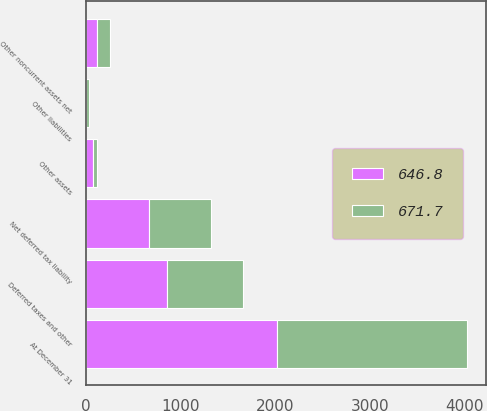Convert chart to OTSL. <chart><loc_0><loc_0><loc_500><loc_500><stacked_bar_chart><ecel><fcel>At December 31<fcel>Other noncurrent assets net<fcel>Other liabilities<fcel>Other assets<fcel>Deferred taxes and other<fcel>Net deferred tax liability<nl><fcel>646.8<fcel>2016<fcel>119.5<fcel>6.3<fcel>74.6<fcel>859.5<fcel>671.7<nl><fcel>671.7<fcel>2015<fcel>135.7<fcel>25<fcel>44.9<fcel>802.4<fcel>646.8<nl></chart> 